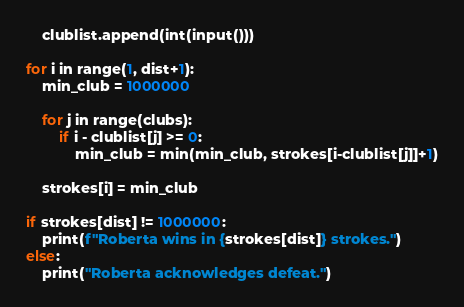Convert code to text. <code><loc_0><loc_0><loc_500><loc_500><_Python_>    clublist.append(int(input()))

for i in range(1, dist+1):
    min_club = 1000000

    for j in range(clubs):
        if i - clublist[j] >= 0:
            min_club = min(min_club, strokes[i-clublist[j]]+1)

    strokes[i] = min_club

if strokes[dist] != 1000000:
    print(f"Roberta wins in {strokes[dist]} strokes.")
else:
    print("Roberta acknowledges defeat.")
</code> 